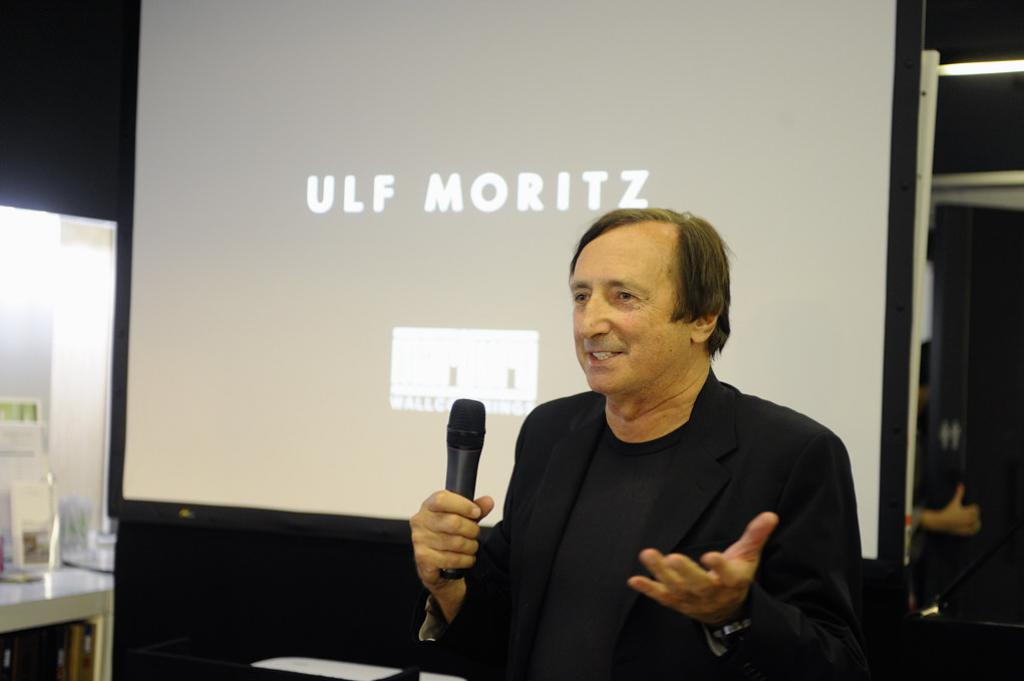What is the main subject of the image? There is a person in the image. What is the person wearing? The person is wearing clothes. What is the person holding in his hand? The person is holding a mic with his hand. What can be seen in the middle of the image? There is a screen in the middle of the image. How does the person's vacation affect the image? There is no mention of a vacation in the image or the provided facts, so it cannot be determined how a vacation might affect the image. 